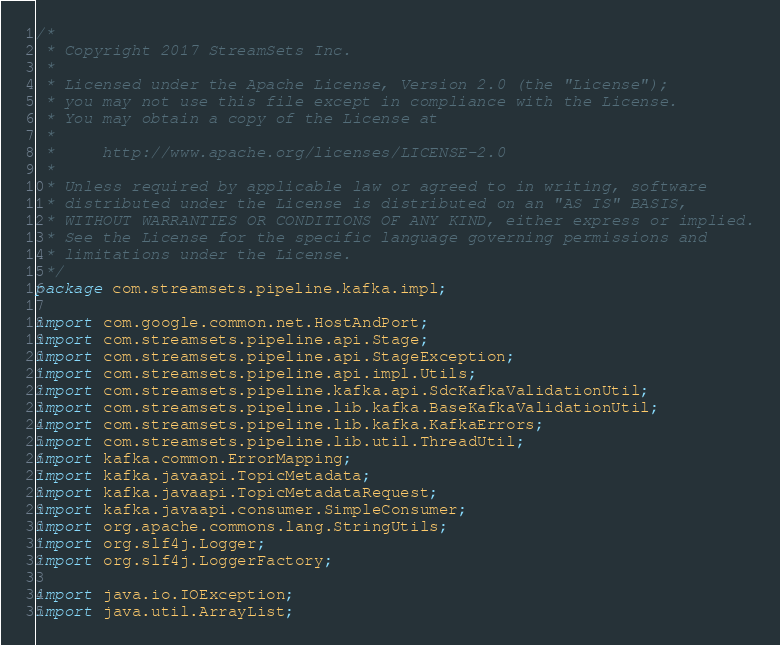Convert code to text. <code><loc_0><loc_0><loc_500><loc_500><_Java_>/*
 * Copyright 2017 StreamSets Inc.
 *
 * Licensed under the Apache License, Version 2.0 (the "License");
 * you may not use this file except in compliance with the License.
 * You may obtain a copy of the License at
 *
 *     http://www.apache.org/licenses/LICENSE-2.0
 *
 * Unless required by applicable law or agreed to in writing, software
 * distributed under the License is distributed on an "AS IS" BASIS,
 * WITHOUT WARRANTIES OR CONDITIONS OF ANY KIND, either express or implied.
 * See the License for the specific language governing permissions and
 * limitations under the License.
 */
package com.streamsets.pipeline.kafka.impl;

import com.google.common.net.HostAndPort;
import com.streamsets.pipeline.api.Stage;
import com.streamsets.pipeline.api.StageException;
import com.streamsets.pipeline.api.impl.Utils;
import com.streamsets.pipeline.kafka.api.SdcKafkaValidationUtil;
import com.streamsets.pipeline.lib.kafka.BaseKafkaValidationUtil;
import com.streamsets.pipeline.lib.kafka.KafkaErrors;
import com.streamsets.pipeline.lib.util.ThreadUtil;
import kafka.common.ErrorMapping;
import kafka.javaapi.TopicMetadata;
import kafka.javaapi.TopicMetadataRequest;
import kafka.javaapi.consumer.SimpleConsumer;
import org.apache.commons.lang.StringUtils;
import org.slf4j.Logger;
import org.slf4j.LoggerFactory;

import java.io.IOException;
import java.util.ArrayList;</code> 